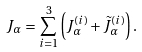<formula> <loc_0><loc_0><loc_500><loc_500>J _ { \alpha } = \sum _ { i = 1 } ^ { 3 } \left ( J _ { \alpha } ^ { ( i ) } + \tilde { J } _ { \alpha } ^ { ( i ) } \right ) .</formula> 